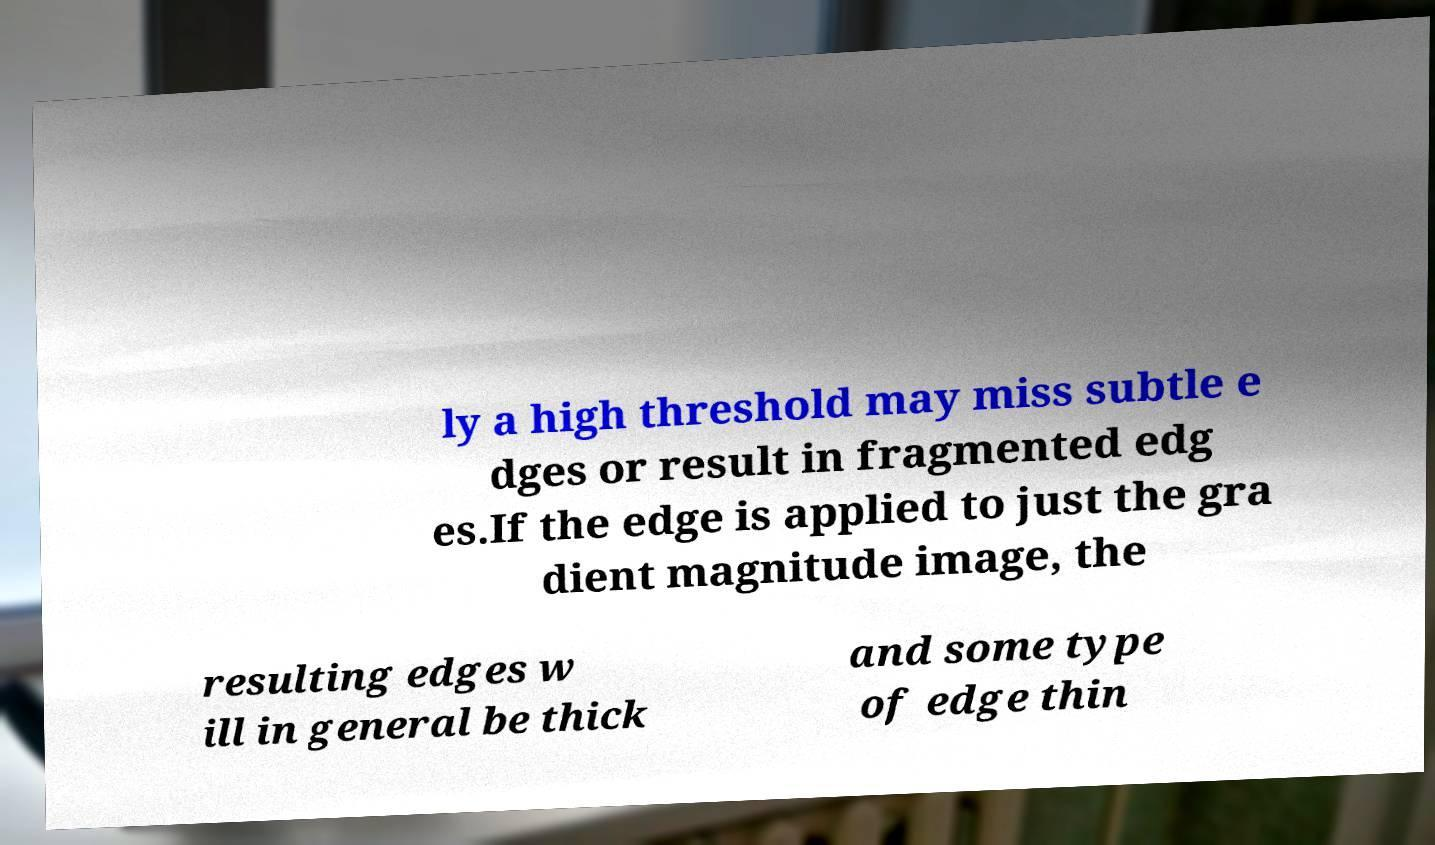Please identify and transcribe the text found in this image. ly a high threshold may miss subtle e dges or result in fragmented edg es.If the edge is applied to just the gra dient magnitude image, the resulting edges w ill in general be thick and some type of edge thin 